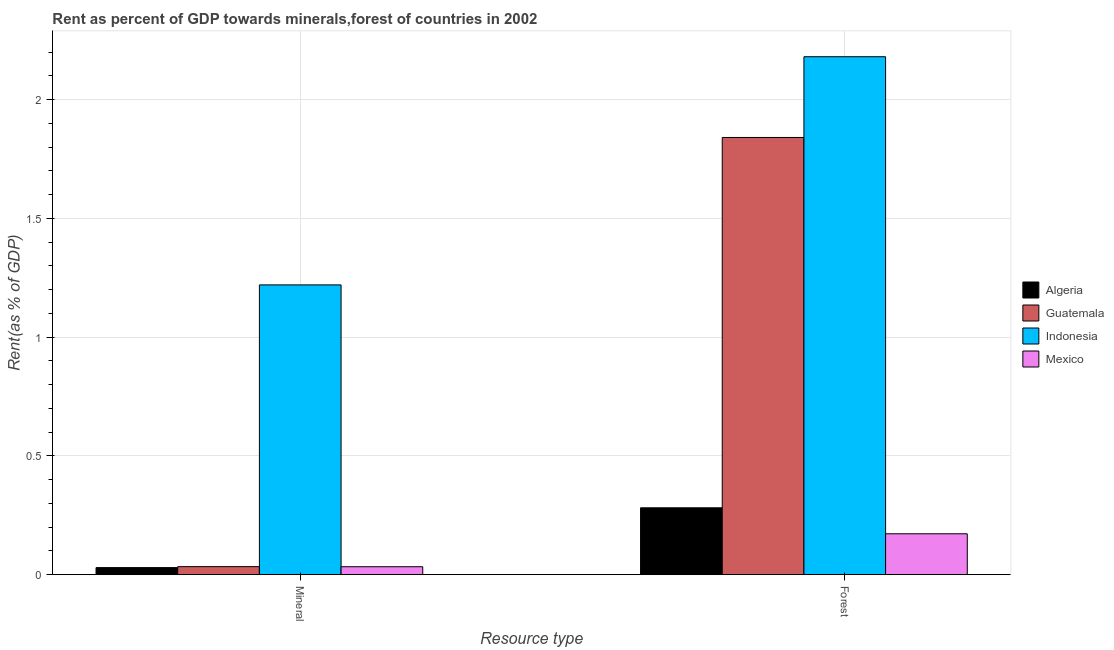Are the number of bars per tick equal to the number of legend labels?
Your answer should be very brief. Yes. How many bars are there on the 2nd tick from the left?
Give a very brief answer. 4. What is the label of the 1st group of bars from the left?
Your answer should be very brief. Mineral. What is the forest rent in Algeria?
Provide a succinct answer. 0.28. Across all countries, what is the maximum forest rent?
Give a very brief answer. 2.18. Across all countries, what is the minimum forest rent?
Offer a very short reply. 0.17. In which country was the mineral rent maximum?
Provide a short and direct response. Indonesia. In which country was the mineral rent minimum?
Offer a terse response. Algeria. What is the total mineral rent in the graph?
Your answer should be very brief. 1.32. What is the difference between the forest rent in Mexico and that in Indonesia?
Your answer should be very brief. -2.01. What is the difference between the forest rent in Algeria and the mineral rent in Indonesia?
Provide a short and direct response. -0.94. What is the average mineral rent per country?
Make the answer very short. 0.33. What is the difference between the mineral rent and forest rent in Indonesia?
Your answer should be compact. -0.96. What is the ratio of the mineral rent in Mexico to that in Guatemala?
Make the answer very short. 0.99. What does the 2nd bar from the left in Forest represents?
Make the answer very short. Guatemala. Are all the bars in the graph horizontal?
Ensure brevity in your answer.  No. What is the difference between two consecutive major ticks on the Y-axis?
Offer a terse response. 0.5. Does the graph contain any zero values?
Your response must be concise. No. Does the graph contain grids?
Your response must be concise. Yes. Where does the legend appear in the graph?
Ensure brevity in your answer.  Center right. What is the title of the graph?
Your response must be concise. Rent as percent of GDP towards minerals,forest of countries in 2002. Does "Greece" appear as one of the legend labels in the graph?
Provide a short and direct response. No. What is the label or title of the X-axis?
Your answer should be compact. Resource type. What is the label or title of the Y-axis?
Your answer should be very brief. Rent(as % of GDP). What is the Rent(as % of GDP) of Algeria in Mineral?
Provide a short and direct response. 0.03. What is the Rent(as % of GDP) of Guatemala in Mineral?
Your answer should be very brief. 0.03. What is the Rent(as % of GDP) of Indonesia in Mineral?
Your answer should be very brief. 1.22. What is the Rent(as % of GDP) of Mexico in Mineral?
Offer a terse response. 0.03. What is the Rent(as % of GDP) of Algeria in Forest?
Offer a very short reply. 0.28. What is the Rent(as % of GDP) of Guatemala in Forest?
Give a very brief answer. 1.84. What is the Rent(as % of GDP) of Indonesia in Forest?
Your response must be concise. 2.18. What is the Rent(as % of GDP) in Mexico in Forest?
Your answer should be compact. 0.17. Across all Resource type, what is the maximum Rent(as % of GDP) in Algeria?
Offer a very short reply. 0.28. Across all Resource type, what is the maximum Rent(as % of GDP) in Guatemala?
Make the answer very short. 1.84. Across all Resource type, what is the maximum Rent(as % of GDP) of Indonesia?
Provide a short and direct response. 2.18. Across all Resource type, what is the maximum Rent(as % of GDP) in Mexico?
Your answer should be compact. 0.17. Across all Resource type, what is the minimum Rent(as % of GDP) in Algeria?
Your response must be concise. 0.03. Across all Resource type, what is the minimum Rent(as % of GDP) in Guatemala?
Offer a terse response. 0.03. Across all Resource type, what is the minimum Rent(as % of GDP) in Indonesia?
Ensure brevity in your answer.  1.22. Across all Resource type, what is the minimum Rent(as % of GDP) of Mexico?
Your response must be concise. 0.03. What is the total Rent(as % of GDP) of Algeria in the graph?
Make the answer very short. 0.31. What is the total Rent(as % of GDP) of Guatemala in the graph?
Give a very brief answer. 1.87. What is the total Rent(as % of GDP) of Indonesia in the graph?
Keep it short and to the point. 3.4. What is the total Rent(as % of GDP) of Mexico in the graph?
Ensure brevity in your answer.  0.21. What is the difference between the Rent(as % of GDP) in Algeria in Mineral and that in Forest?
Keep it short and to the point. -0.25. What is the difference between the Rent(as % of GDP) in Guatemala in Mineral and that in Forest?
Keep it short and to the point. -1.81. What is the difference between the Rent(as % of GDP) in Indonesia in Mineral and that in Forest?
Provide a succinct answer. -0.96. What is the difference between the Rent(as % of GDP) of Mexico in Mineral and that in Forest?
Give a very brief answer. -0.14. What is the difference between the Rent(as % of GDP) in Algeria in Mineral and the Rent(as % of GDP) in Guatemala in Forest?
Give a very brief answer. -1.81. What is the difference between the Rent(as % of GDP) of Algeria in Mineral and the Rent(as % of GDP) of Indonesia in Forest?
Provide a succinct answer. -2.15. What is the difference between the Rent(as % of GDP) in Algeria in Mineral and the Rent(as % of GDP) in Mexico in Forest?
Provide a short and direct response. -0.14. What is the difference between the Rent(as % of GDP) in Guatemala in Mineral and the Rent(as % of GDP) in Indonesia in Forest?
Your answer should be compact. -2.15. What is the difference between the Rent(as % of GDP) of Guatemala in Mineral and the Rent(as % of GDP) of Mexico in Forest?
Keep it short and to the point. -0.14. What is the difference between the Rent(as % of GDP) in Indonesia in Mineral and the Rent(as % of GDP) in Mexico in Forest?
Make the answer very short. 1.05. What is the average Rent(as % of GDP) in Algeria per Resource type?
Give a very brief answer. 0.16. What is the average Rent(as % of GDP) of Guatemala per Resource type?
Your answer should be compact. 0.94. What is the average Rent(as % of GDP) in Indonesia per Resource type?
Your answer should be compact. 1.7. What is the average Rent(as % of GDP) of Mexico per Resource type?
Your response must be concise. 0.1. What is the difference between the Rent(as % of GDP) in Algeria and Rent(as % of GDP) in Guatemala in Mineral?
Provide a short and direct response. -0. What is the difference between the Rent(as % of GDP) in Algeria and Rent(as % of GDP) in Indonesia in Mineral?
Your response must be concise. -1.19. What is the difference between the Rent(as % of GDP) of Algeria and Rent(as % of GDP) of Mexico in Mineral?
Offer a terse response. -0. What is the difference between the Rent(as % of GDP) of Guatemala and Rent(as % of GDP) of Indonesia in Mineral?
Make the answer very short. -1.19. What is the difference between the Rent(as % of GDP) in Guatemala and Rent(as % of GDP) in Mexico in Mineral?
Offer a terse response. 0. What is the difference between the Rent(as % of GDP) in Indonesia and Rent(as % of GDP) in Mexico in Mineral?
Make the answer very short. 1.19. What is the difference between the Rent(as % of GDP) in Algeria and Rent(as % of GDP) in Guatemala in Forest?
Make the answer very short. -1.56. What is the difference between the Rent(as % of GDP) of Algeria and Rent(as % of GDP) of Indonesia in Forest?
Your answer should be very brief. -1.9. What is the difference between the Rent(as % of GDP) of Algeria and Rent(as % of GDP) of Mexico in Forest?
Your response must be concise. 0.11. What is the difference between the Rent(as % of GDP) of Guatemala and Rent(as % of GDP) of Indonesia in Forest?
Provide a succinct answer. -0.34. What is the difference between the Rent(as % of GDP) in Guatemala and Rent(as % of GDP) in Mexico in Forest?
Keep it short and to the point. 1.67. What is the difference between the Rent(as % of GDP) in Indonesia and Rent(as % of GDP) in Mexico in Forest?
Give a very brief answer. 2.01. What is the ratio of the Rent(as % of GDP) in Algeria in Mineral to that in Forest?
Your response must be concise. 0.11. What is the ratio of the Rent(as % of GDP) of Guatemala in Mineral to that in Forest?
Offer a very short reply. 0.02. What is the ratio of the Rent(as % of GDP) of Indonesia in Mineral to that in Forest?
Make the answer very short. 0.56. What is the ratio of the Rent(as % of GDP) of Mexico in Mineral to that in Forest?
Provide a short and direct response. 0.19. What is the difference between the highest and the second highest Rent(as % of GDP) of Algeria?
Your response must be concise. 0.25. What is the difference between the highest and the second highest Rent(as % of GDP) in Guatemala?
Your answer should be very brief. 1.81. What is the difference between the highest and the second highest Rent(as % of GDP) in Indonesia?
Keep it short and to the point. 0.96. What is the difference between the highest and the second highest Rent(as % of GDP) of Mexico?
Ensure brevity in your answer.  0.14. What is the difference between the highest and the lowest Rent(as % of GDP) of Algeria?
Give a very brief answer. 0.25. What is the difference between the highest and the lowest Rent(as % of GDP) of Guatemala?
Your answer should be compact. 1.81. What is the difference between the highest and the lowest Rent(as % of GDP) of Indonesia?
Keep it short and to the point. 0.96. What is the difference between the highest and the lowest Rent(as % of GDP) of Mexico?
Offer a very short reply. 0.14. 